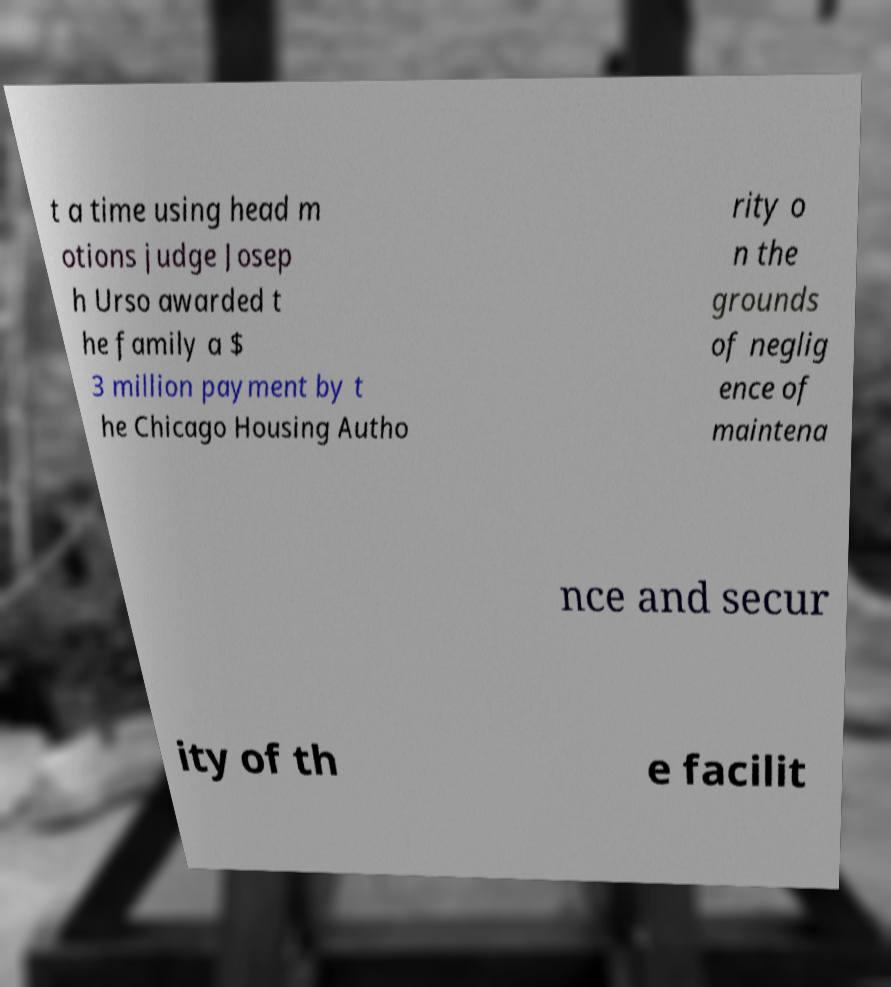Please read and relay the text visible in this image. What does it say? t a time using head m otions judge Josep h Urso awarded t he family a $ 3 million payment by t he Chicago Housing Autho rity o n the grounds of neglig ence of maintena nce and secur ity of th e facilit 